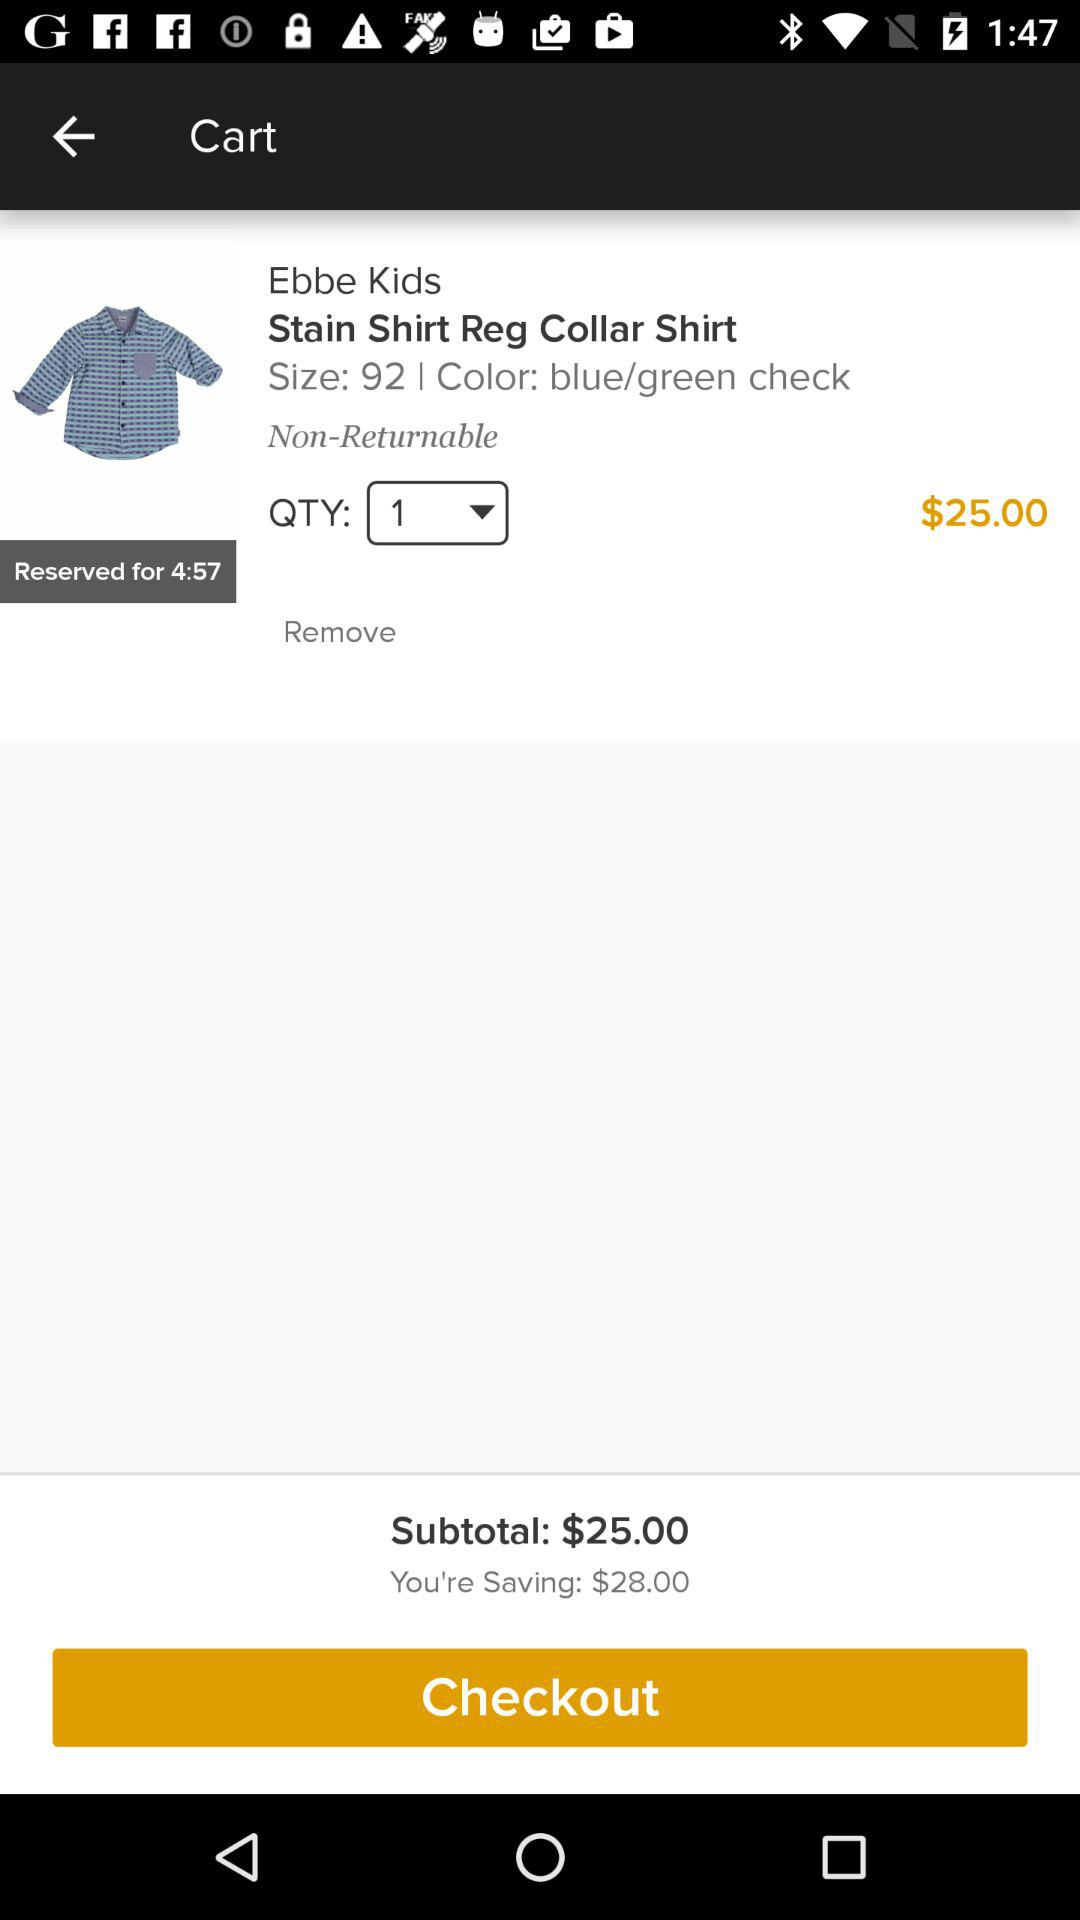What is the price of the shirt? The price is $25.00. 